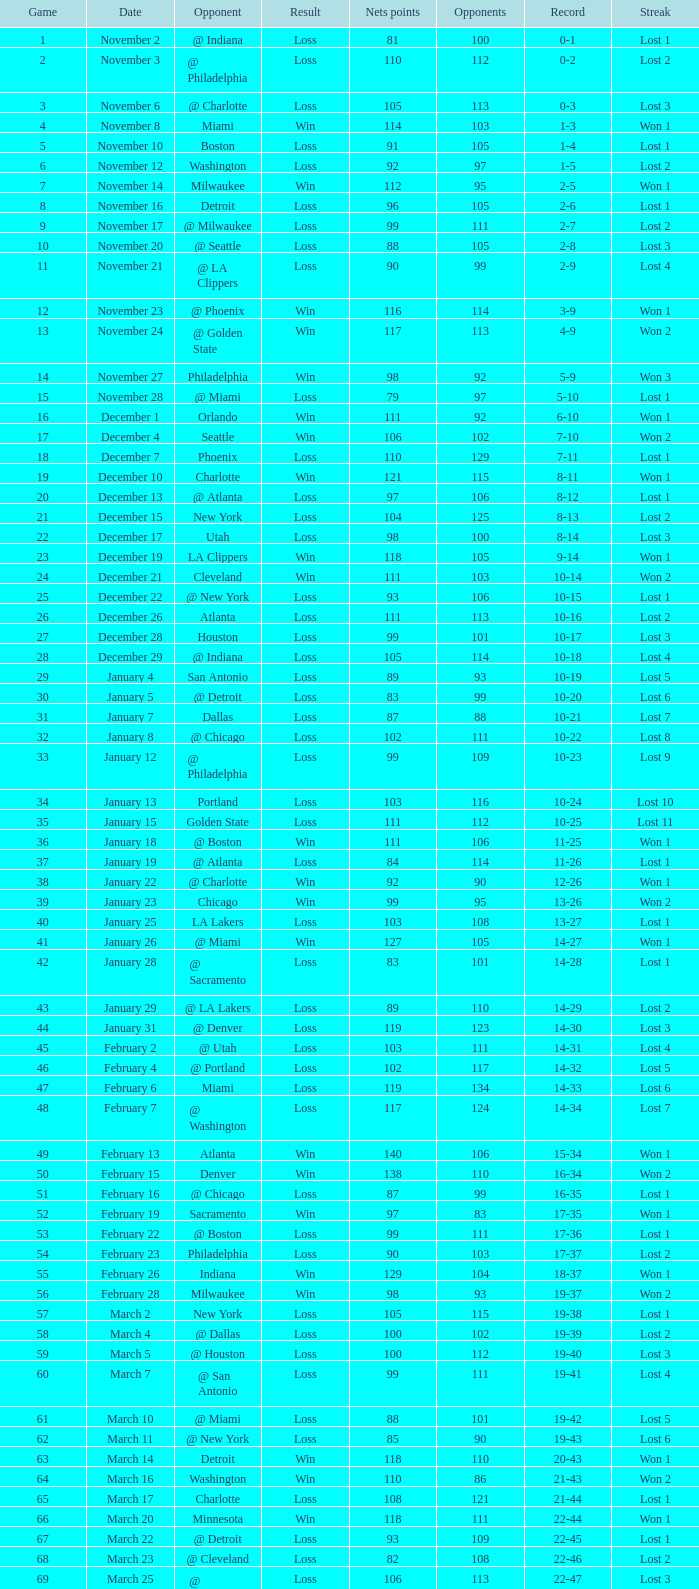In which game did the opponent score more than 103 and the record was 1-3? None. 